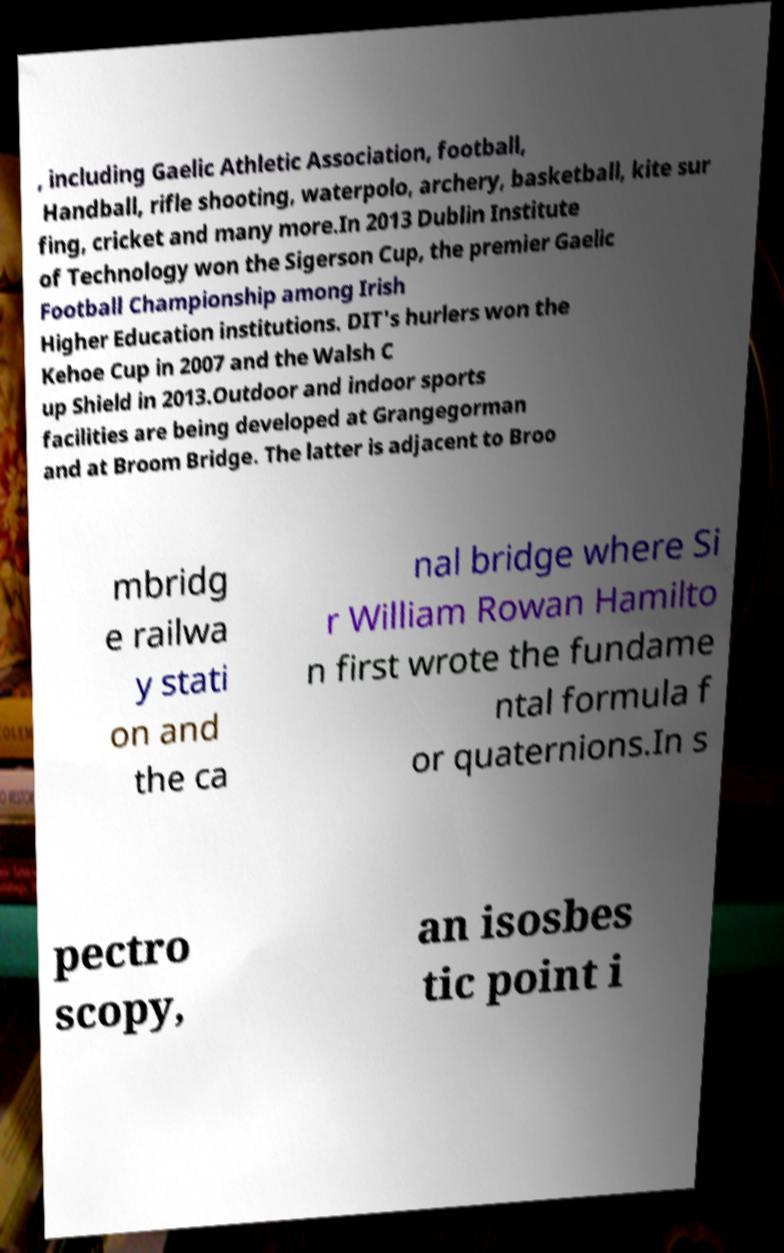Please identify and transcribe the text found in this image. , including Gaelic Athletic Association, football, Handball, rifle shooting, waterpolo, archery, basketball, kite sur fing, cricket and many more.In 2013 Dublin Institute of Technology won the Sigerson Cup, the premier Gaelic Football Championship among Irish Higher Education institutions. DIT's hurlers won the Kehoe Cup in 2007 and the Walsh C up Shield in 2013.Outdoor and indoor sports facilities are being developed at Grangegorman and at Broom Bridge. The latter is adjacent to Broo mbridg e railwa y stati on and the ca nal bridge where Si r William Rowan Hamilto n first wrote the fundame ntal formula f or quaternions.In s pectro scopy, an isosbes tic point i 